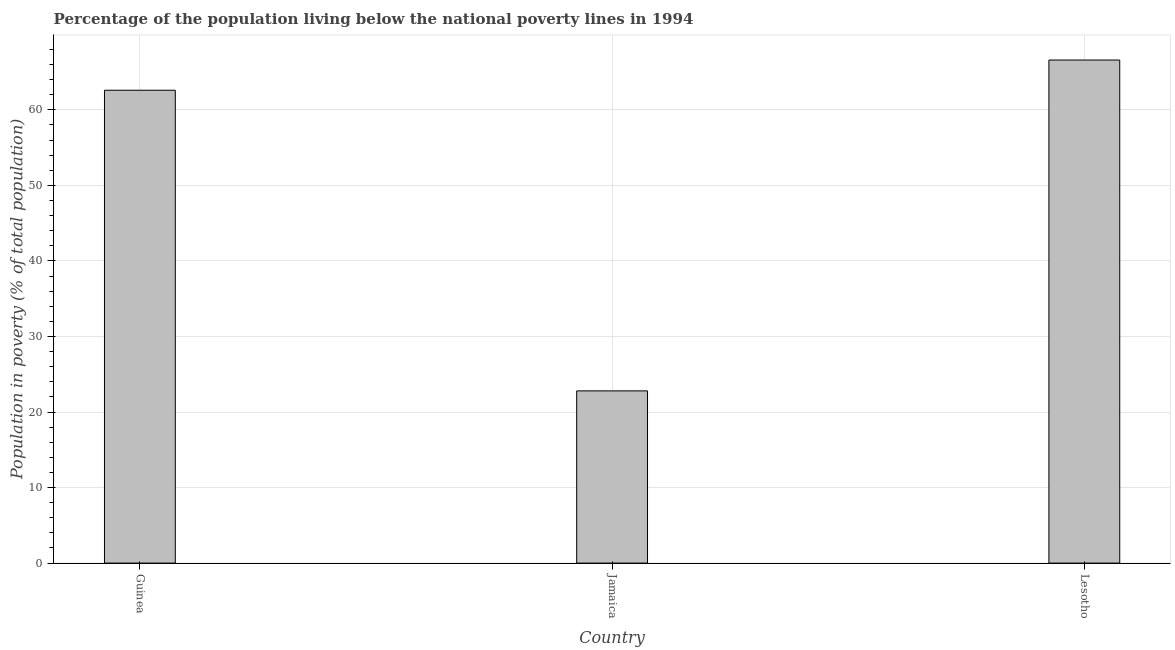What is the title of the graph?
Offer a terse response. Percentage of the population living below the national poverty lines in 1994. What is the label or title of the Y-axis?
Give a very brief answer. Population in poverty (% of total population). What is the percentage of population living below poverty line in Lesotho?
Provide a succinct answer. 66.6. Across all countries, what is the maximum percentage of population living below poverty line?
Give a very brief answer. 66.6. Across all countries, what is the minimum percentage of population living below poverty line?
Make the answer very short. 22.8. In which country was the percentage of population living below poverty line maximum?
Give a very brief answer. Lesotho. In which country was the percentage of population living below poverty line minimum?
Provide a succinct answer. Jamaica. What is the sum of the percentage of population living below poverty line?
Your answer should be compact. 152. What is the difference between the percentage of population living below poverty line in Jamaica and Lesotho?
Make the answer very short. -43.8. What is the average percentage of population living below poverty line per country?
Your answer should be compact. 50.67. What is the median percentage of population living below poverty line?
Keep it short and to the point. 62.6. What is the ratio of the percentage of population living below poverty line in Guinea to that in Jamaica?
Your answer should be very brief. 2.75. Is the difference between the percentage of population living below poverty line in Guinea and Lesotho greater than the difference between any two countries?
Provide a succinct answer. No. Is the sum of the percentage of population living below poverty line in Guinea and Jamaica greater than the maximum percentage of population living below poverty line across all countries?
Provide a succinct answer. Yes. What is the difference between the highest and the lowest percentage of population living below poverty line?
Provide a succinct answer. 43.8. In how many countries, is the percentage of population living below poverty line greater than the average percentage of population living below poverty line taken over all countries?
Ensure brevity in your answer.  2. What is the Population in poverty (% of total population) in Guinea?
Ensure brevity in your answer.  62.6. What is the Population in poverty (% of total population) of Jamaica?
Offer a very short reply. 22.8. What is the Population in poverty (% of total population) in Lesotho?
Offer a very short reply. 66.6. What is the difference between the Population in poverty (% of total population) in Guinea and Jamaica?
Give a very brief answer. 39.8. What is the difference between the Population in poverty (% of total population) in Jamaica and Lesotho?
Offer a very short reply. -43.8. What is the ratio of the Population in poverty (% of total population) in Guinea to that in Jamaica?
Give a very brief answer. 2.75. What is the ratio of the Population in poverty (% of total population) in Guinea to that in Lesotho?
Keep it short and to the point. 0.94. What is the ratio of the Population in poverty (% of total population) in Jamaica to that in Lesotho?
Provide a short and direct response. 0.34. 